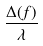Convert formula to latex. <formula><loc_0><loc_0><loc_500><loc_500>\frac { \Delta ( f ) } { \lambda }</formula> 